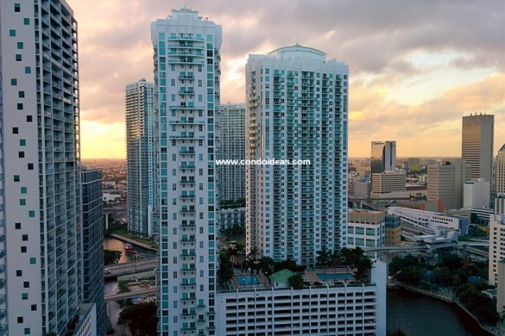Analyze the image in a comprehensive and detailed manner. The image beautifully captures a cityscape at sunset, dominated by a series of tall, white and gray buildings. These skyscrapers are closely packed, forming a dense urban center. A river meanders through the heart of the city, its surface reflecting the warm orange and pink hues of the setting sun in the sky. The sun, just about to dip behind the buildings, casts long shadows and bathes the entire scene in a soft, golden glow, giving the city a serene and peaceful appearance from this high vantage point. In the bottom right corner, there is a watermark reading 'www.condoideas.com,' likely indicating the image's source. The overall scene represents a moment of calm in the busy life of the city as it transitions from day to night. 